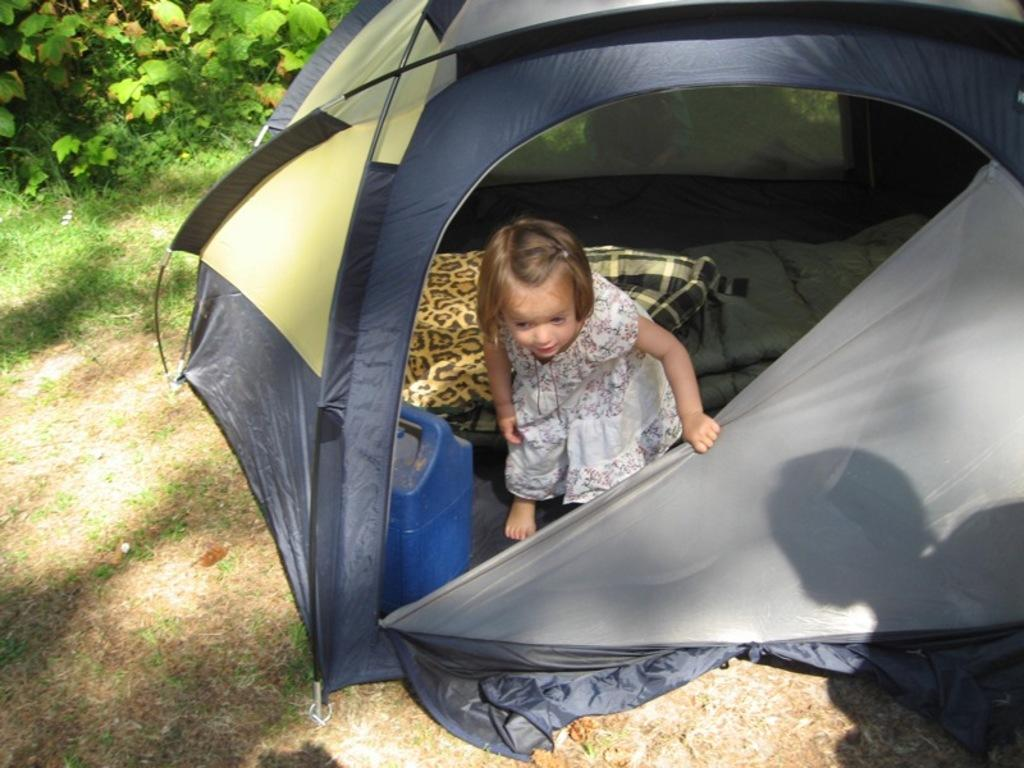What is the main subject of the image? There is a kid in the image. Where is the kid located? The kid is in a camping tent. What can be seen inside the tent with the kid? There is a bed inside the camping tent. What is visible in the top left corner of the image? There are plants and grass in the top left corner of the image. Can you see any lace on the kid's clothing in the image? There is no information about the kid's clothing in the provided facts, so it cannot be determined if there is any lace present. Is the kid walking in the image? The provided facts do not mention the kid's actions, so it cannot be determined if the kid is walking. 